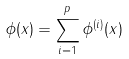Convert formula to latex. <formula><loc_0><loc_0><loc_500><loc_500>\phi ( x ) = \sum _ { i = 1 } ^ { p } \phi ^ { ( i ) } ( x )</formula> 